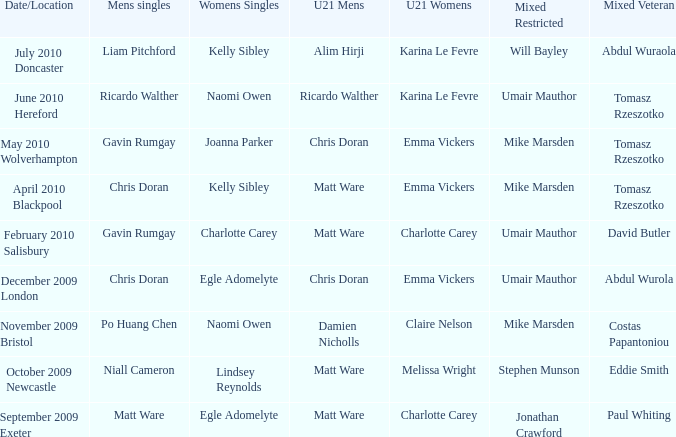Would you be able to parse every entry in this table? {'header': ['Date/Location', 'Mens singles', 'Womens Singles', 'U21 Mens', 'U21 Womens', 'Mixed Restricted', 'Mixed Veteran'], 'rows': [['July 2010 Doncaster', 'Liam Pitchford', 'Kelly Sibley', 'Alim Hirji', 'Karina Le Fevre', 'Will Bayley', 'Abdul Wuraola'], ['June 2010 Hereford', 'Ricardo Walther', 'Naomi Owen', 'Ricardo Walther', 'Karina Le Fevre', 'Umair Mauthor', 'Tomasz Rzeszotko'], ['May 2010 Wolverhampton', 'Gavin Rumgay', 'Joanna Parker', 'Chris Doran', 'Emma Vickers', 'Mike Marsden', 'Tomasz Rzeszotko'], ['April 2010 Blackpool', 'Chris Doran', 'Kelly Sibley', 'Matt Ware', 'Emma Vickers', 'Mike Marsden', 'Tomasz Rzeszotko'], ['February 2010 Salisbury', 'Gavin Rumgay', 'Charlotte Carey', 'Matt Ware', 'Charlotte Carey', 'Umair Mauthor', 'David Butler'], ['December 2009 London', 'Chris Doran', 'Egle Adomelyte', 'Chris Doran', 'Emma Vickers', 'Umair Mauthor', 'Abdul Wurola'], ['November 2009 Bristol', 'Po Huang Chen', 'Naomi Owen', 'Damien Nicholls', 'Claire Nelson', 'Mike Marsden', 'Costas Papantoniou'], ['October 2009 Newcastle', 'Niall Cameron', 'Lindsey Reynolds', 'Matt Ware', 'Melissa Wright', 'Stephen Munson', 'Eddie Smith'], ['September 2009 Exeter', 'Matt Ware', 'Egle Adomelyte', 'Matt Ware', 'Charlotte Carey', 'Jonathan Crawford', 'Paul Whiting']]} When matt ware triumphed in the men's singles, who was victorious in the mixed restricted? Jonathan Crawford. 